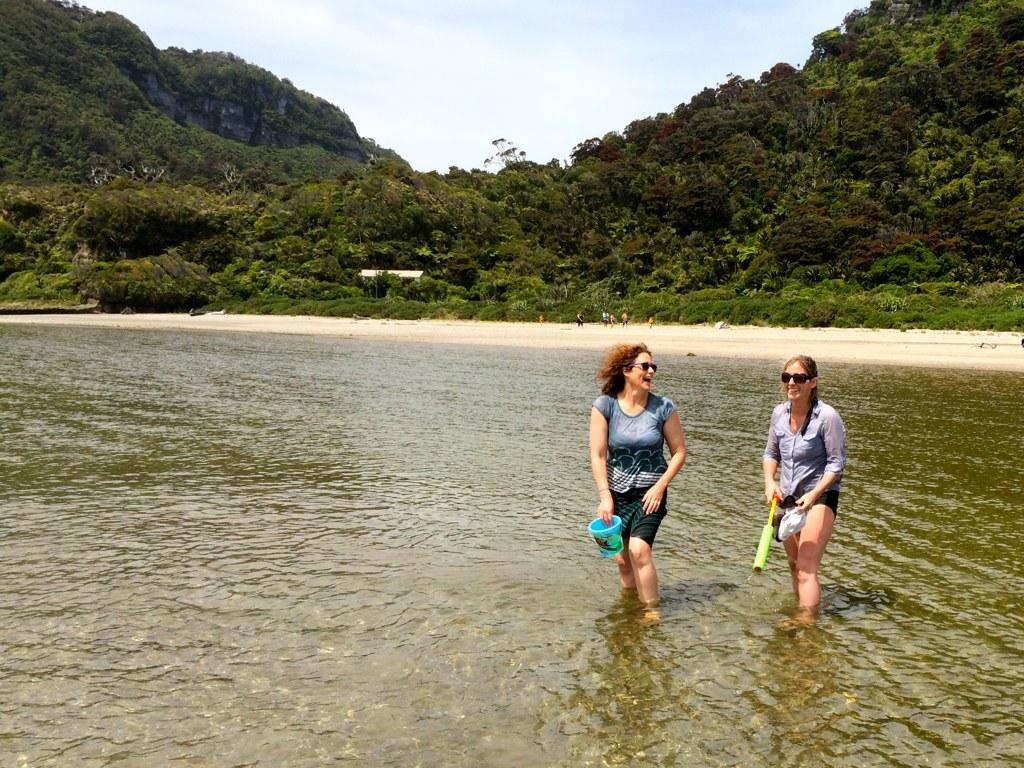How many women are in the image? There are two women in the image. What expression do the women have? The women are smiling. What are the women wearing on their faces? The women are wearing goggles. What are the women holding in their hands? The women are holding objects. What can be seen in the image besides the women? There is water visible in the image, as well as trees, people, and the sky in the background. What type of linen can be seen hanging from the mailbox in the image? There is no linen or mailbox present in the image. What is the name of the downtown area visible in the image? There is no downtown area visible in the image. 